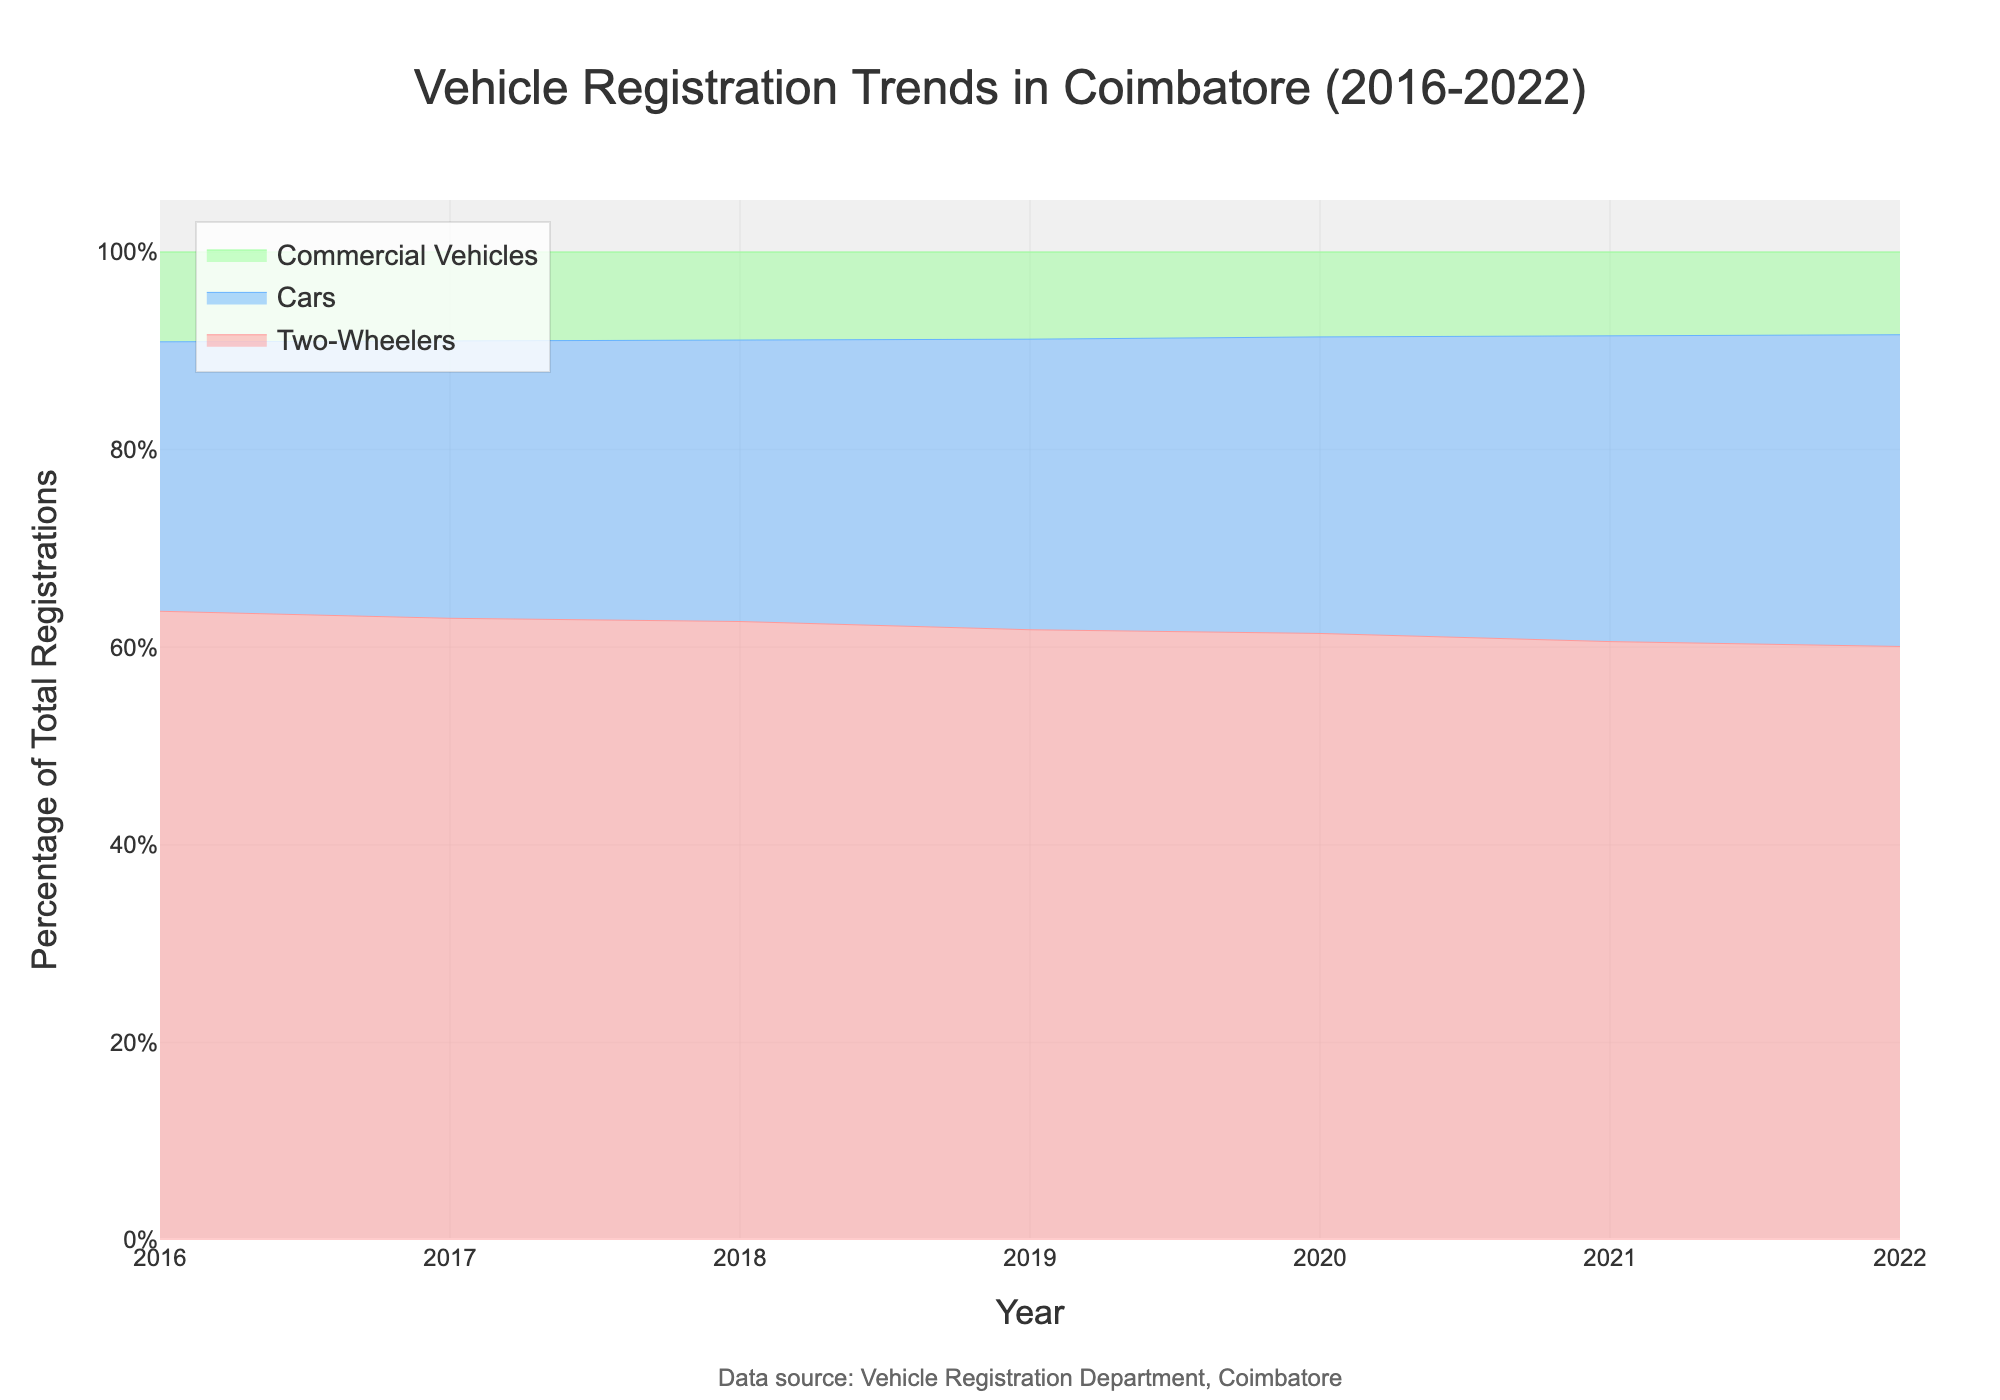What is the title of the plot? The title is prominently displayed at the top of the graph. It summarizes the main topic of the graph, which is vehicle registration trends in Coimbatore from 2016 to 2022.
Answer: Vehicle Registration Trends in Coimbatore (2016-2022) Which type of vehicle had the highest percentage of registrations over the years? By observing the stream graph, one can see that the area representing Two-Wheelers is consistently the largest. This indicates that Two-Wheelers had the highest percentage of registrations over the years.
Answer: Two-Wheelers How did Car registrations change from 2016 to 2022? By following the blue area representing Cars from left (2016) to right (2022) in the graph, it shows a consistent increase in Car registrations over the years.
Answer: Increased Which year had the highest percentage of Commercial Vehicle registrations? Look for the green area that represents Commercial Vehicles. By comparing the thickness of the green segment each year, one can see that the year 2022 has the highest percentage.
Answer: 2022 Did Two-Wheeler registrations increase or decrease from 2016 to 2022? Observing the pink area from the left (2016) to the right (2022), it shows a continuous increase in Two-Wheeler registrations over the period.
Answer: Increased What was the growth trend of overall vehicle registrations from 2016 to 2022? Since all areas (blue for Cars, pink for Two-Wheelers, and green for Commercial Vehicles) consistently grow in size from left to right, it indicates an overall increasing trend in vehicle registrations from 2016 to 2022.
Answer: Increasing Between 2017 and 2021, which type of vehicle showed the highest increase in registrations? By comparing the increase in size for each color band (blue for Cars, pink for Two-Wheelers, green for Commercial Vehicles) between 2017 and 2021, Two-Wheelers show a more significant increase than the other vehicle types.
Answer: Two-Wheelers What is the percentage trendline for Commercial Vehicles from 2016 to 2022? Follow the green area (Commercial Vehicles) from 2016 to 2022. The band consistently widens slightly, showing a steady, albeit slower, increase over the years.
Answer: Steady Increase 